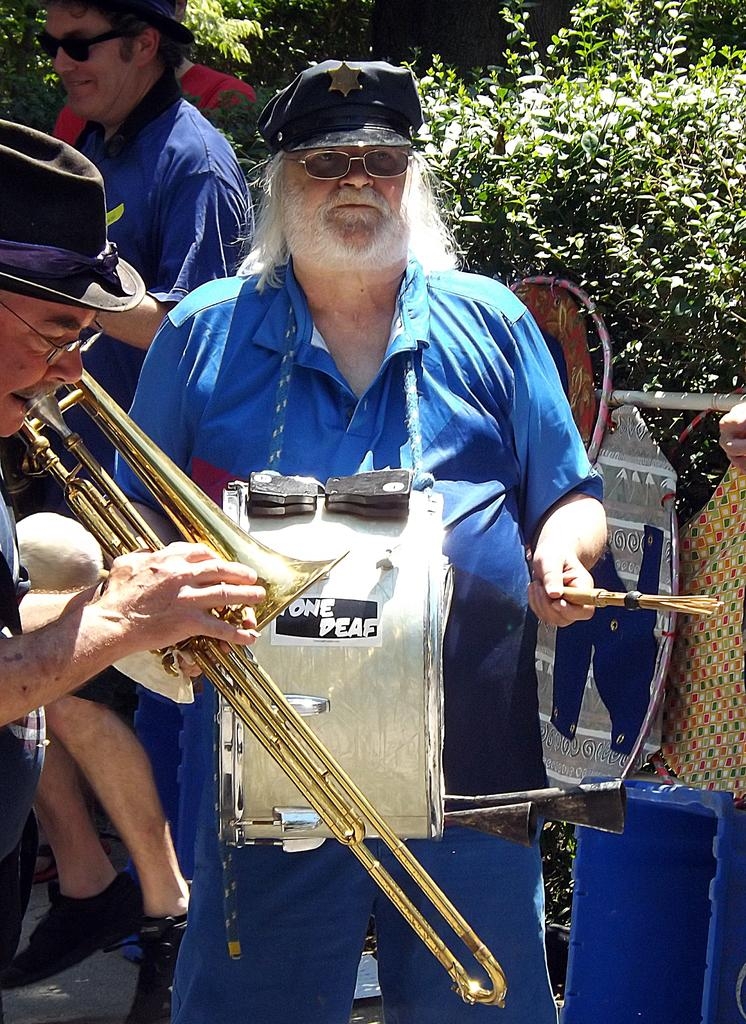What are the people in the image doing? The people in the image are holding musical instruments. What can be seen in the background of the image? There are trees visible in the background of the image. What is located on the right side of the image? There are objects on the right side of the image. How much sugar is in the friend's coffee on the left side of the image? There is no friend or coffee present in the image; it only features people holding musical instruments and trees in the background. 